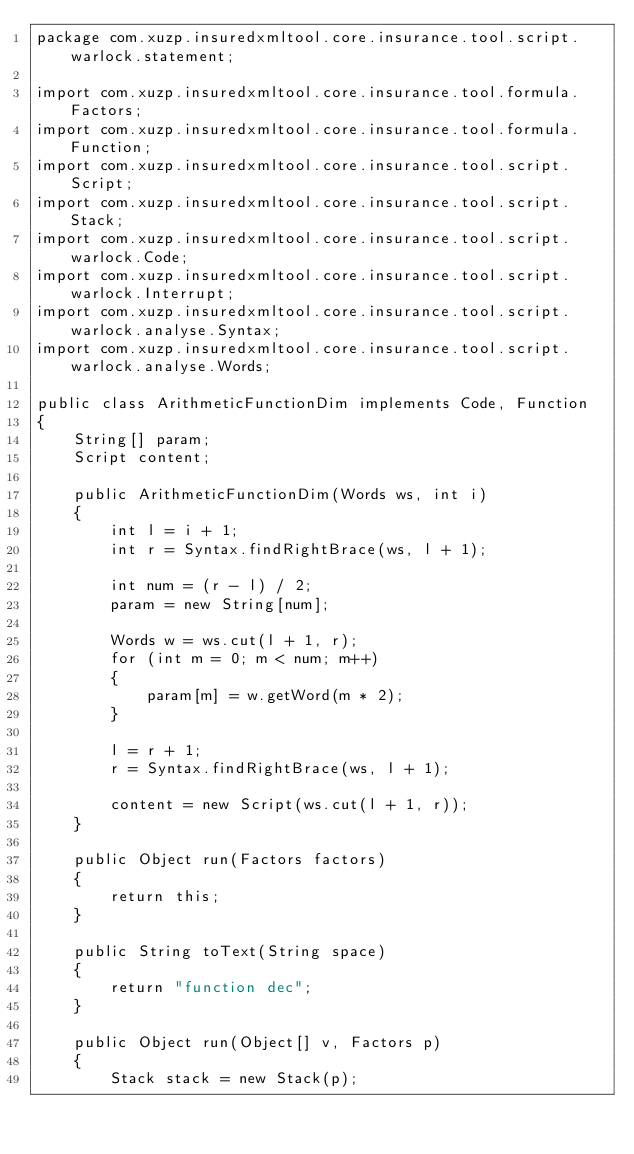Convert code to text. <code><loc_0><loc_0><loc_500><loc_500><_Java_>package com.xuzp.insuredxmltool.core.insurance.tool.script.warlock.statement;

import com.xuzp.insuredxmltool.core.insurance.tool.formula.Factors;
import com.xuzp.insuredxmltool.core.insurance.tool.formula.Function;
import com.xuzp.insuredxmltool.core.insurance.tool.script.Script;
import com.xuzp.insuredxmltool.core.insurance.tool.script.Stack;
import com.xuzp.insuredxmltool.core.insurance.tool.script.warlock.Code;
import com.xuzp.insuredxmltool.core.insurance.tool.script.warlock.Interrupt;
import com.xuzp.insuredxmltool.core.insurance.tool.script.warlock.analyse.Syntax;
import com.xuzp.insuredxmltool.core.insurance.tool.script.warlock.analyse.Words;

public class ArithmeticFunctionDim implements Code, Function
{
	String[] param;
	Script content;
	
	public ArithmeticFunctionDim(Words ws, int i)
	{
		int l = i + 1;
		int r = Syntax.findRightBrace(ws, l + 1);

		int num = (r - l) / 2;
		param = new String[num];

		Words w = ws.cut(l + 1, r);
		for (int m = 0; m < num; m++)
		{
			param[m] = w.getWord(m * 2);
		}

		l = r + 1;
		r = Syntax.findRightBrace(ws, l + 1);
		
		content = new Script(ws.cut(l + 1, r));
	}

	public Object run(Factors factors)
	{
		return this;
	}

	public String toText(String space)
	{
		return "function dec";
	}

	public Object run(Object[] v, Factors p)
	{
		Stack stack = new Stack(p);
		</code> 